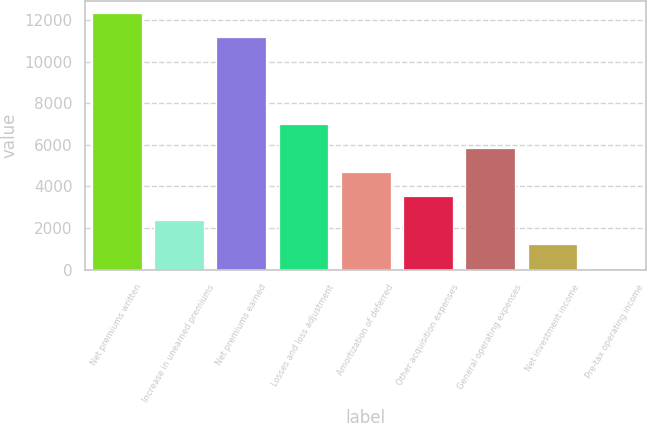Convert chart. <chart><loc_0><loc_0><loc_500><loc_500><bar_chart><fcel>Net premiums written<fcel>Increase in unearned premiums<fcel>Net premiums earned<fcel>Losses and loss adjustment<fcel>Amortization of deferred<fcel>Other acquisition expenses<fcel>General operating expenses<fcel>Net investment income<fcel>Pre-tax operating income<nl><fcel>12308.6<fcel>2375.2<fcel>11158<fcel>6977.6<fcel>4676.4<fcel>3525.8<fcel>5827<fcel>1224.6<fcel>74<nl></chart> 